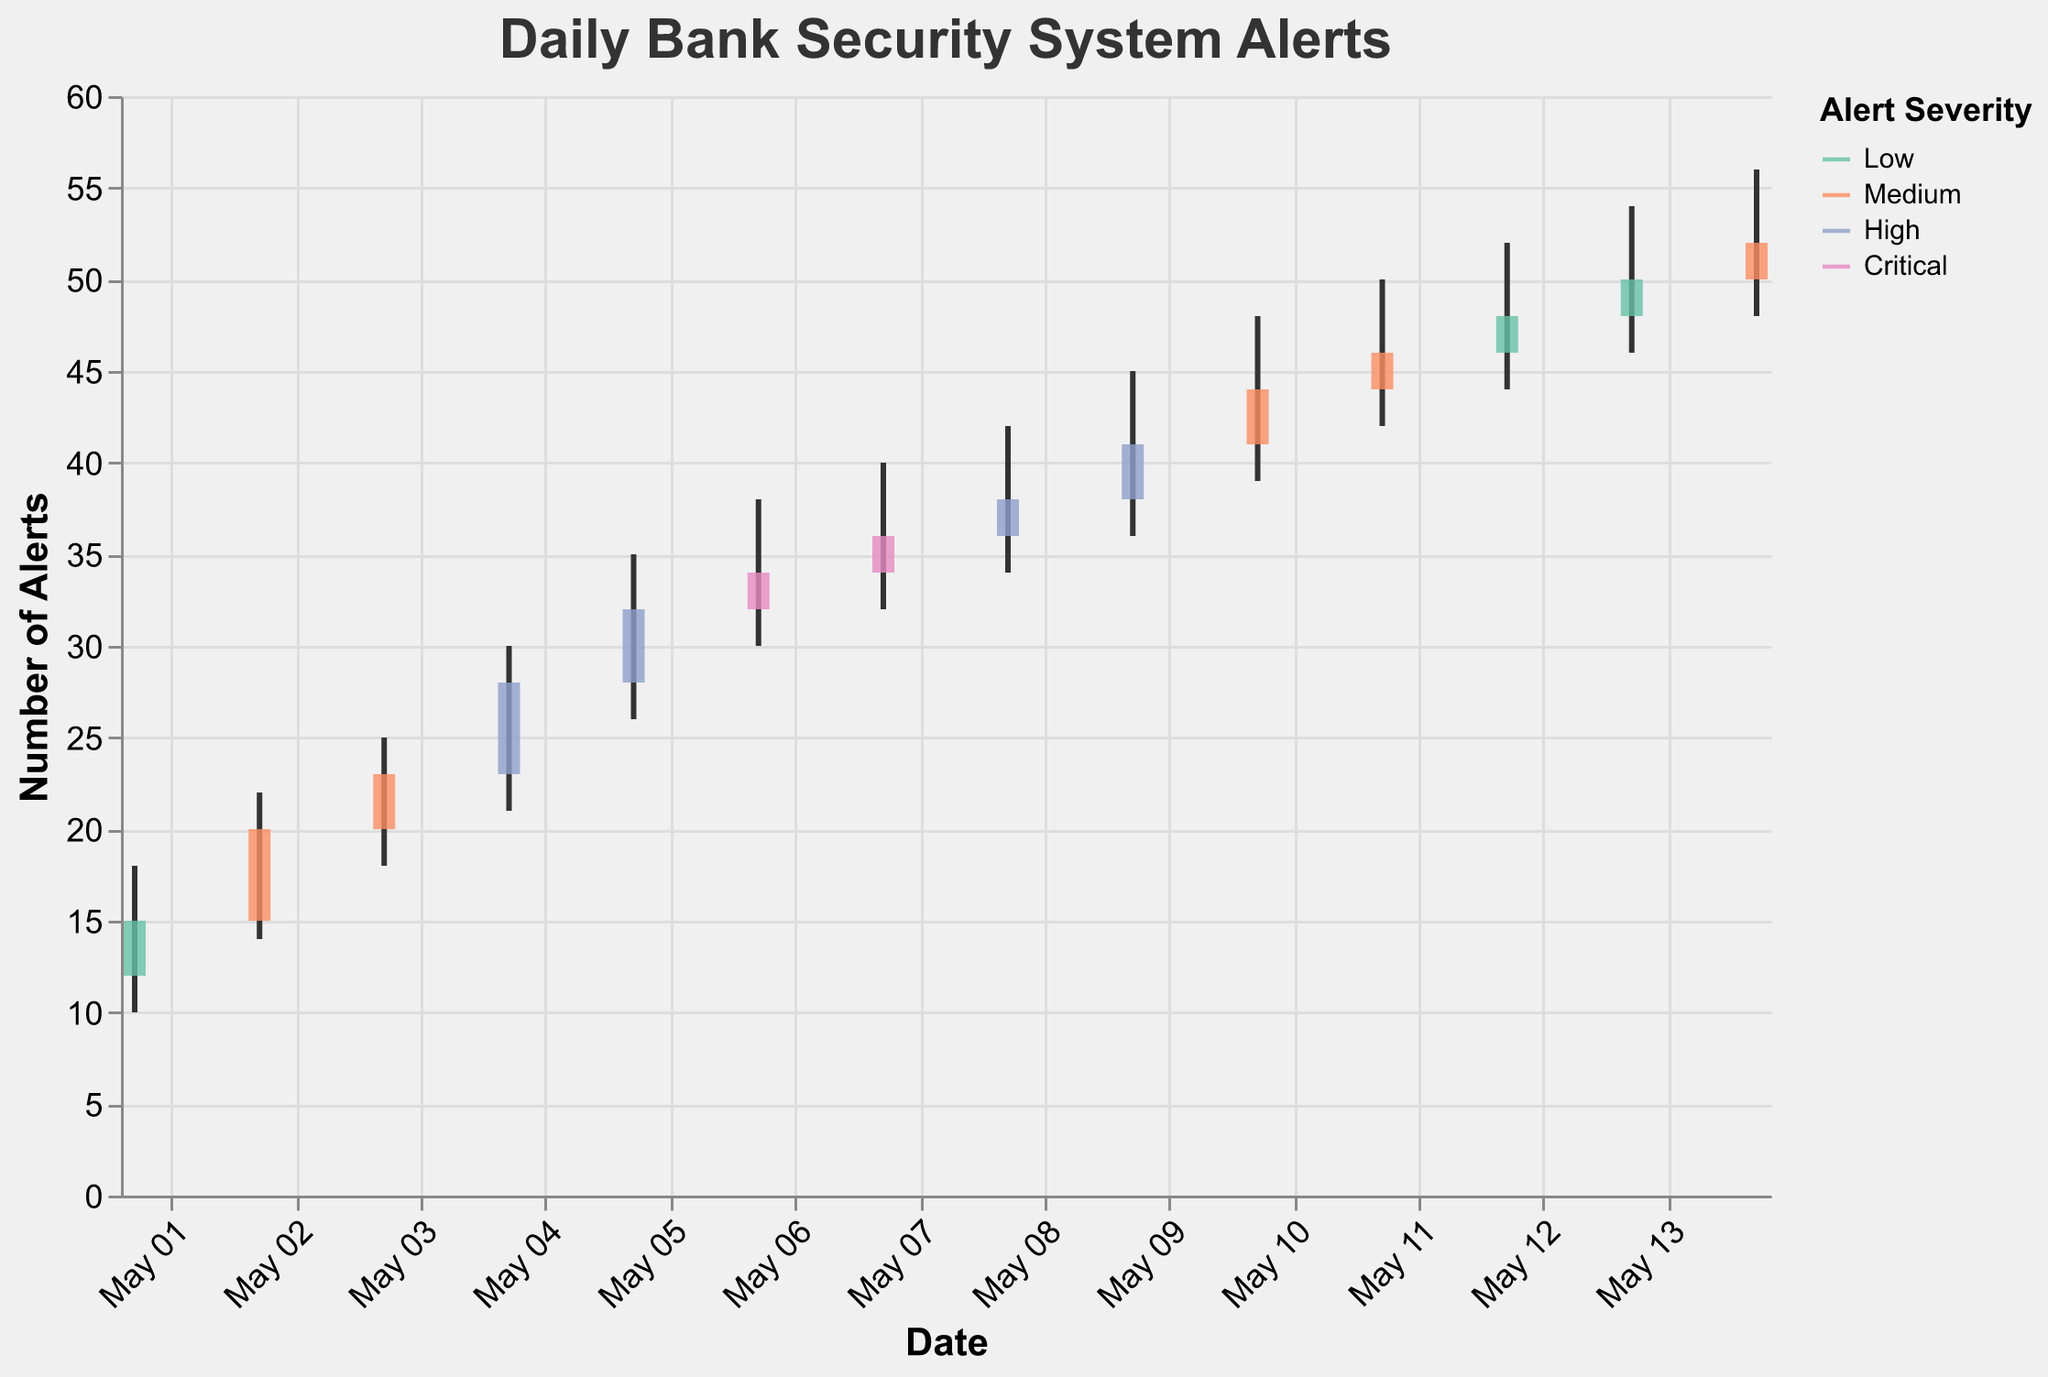How many days are there in the dataset? To count the number of days in the dataset, we simply count all the entries provided. There are 14 dates.
Answer: 14 What is the highest number of alerts recorded on any day and on which day did it occur? The highest number of alerts corresponds to the "High" column. By looking at the dataset, the highest value in the "High" column is 56, which occurred on May 14, 2023.
Answer: 56 on May 14, 2023 On what date did the severity level first reach "Critical"? We need to find the first occurrence of the "Critical" severity level in the dataset. The first "Critical" severity level appears on May 6, 2023.
Answer: May 6, 2023 Which severity levels show the highest and the lowest ranges of fluctuations in alerts? The range of fluctuations for each severity level can be calculated as the difference between the highest and the lowest number of alerts for the corresponding severity levels. The "Critical" severity level (38 to 40, 34 to 36) has the smallest fluctuation range, while "High" (30 to 35, 34 to 42, 36 to 45) shows the highest range.
Answer: Highest: High, Lowest: Critical Which severity level was observed most frequently in the dataset? To find this, we count the occurrences of each severity level. "Medium" occurs 5 times, which is the most frequent in the dataset.
Answer: Medium What is the total number of alerts recorded on May 10, 2023? The total number of alerts can be calculated by noting the "Close" value on May 10, which is 44.
Answer: 44 What was the fluctuation range of the number of alerts on May 4, 2023? The fluctuation range can be calculated as the difference between the highest and the lowest values. For May 4, it is 30 (High) - 21 (Low) = 9.
Answer: 9 During which days did the "High" severity level appear? We look for all dates with the "High" severity level. These are May 4, May 5, May 8, and May 9.
Answer: May 4, May 5, May 8, May 9 How many days had more than 40 alerts recorded as their "High" value? To find this, we look at the "High" values for each day and count the days that have more than 40 alerts. These days are May 9, May 10, May 11, May 12, May 13, and May 14, making a total of 6 days.
Answer: 6 